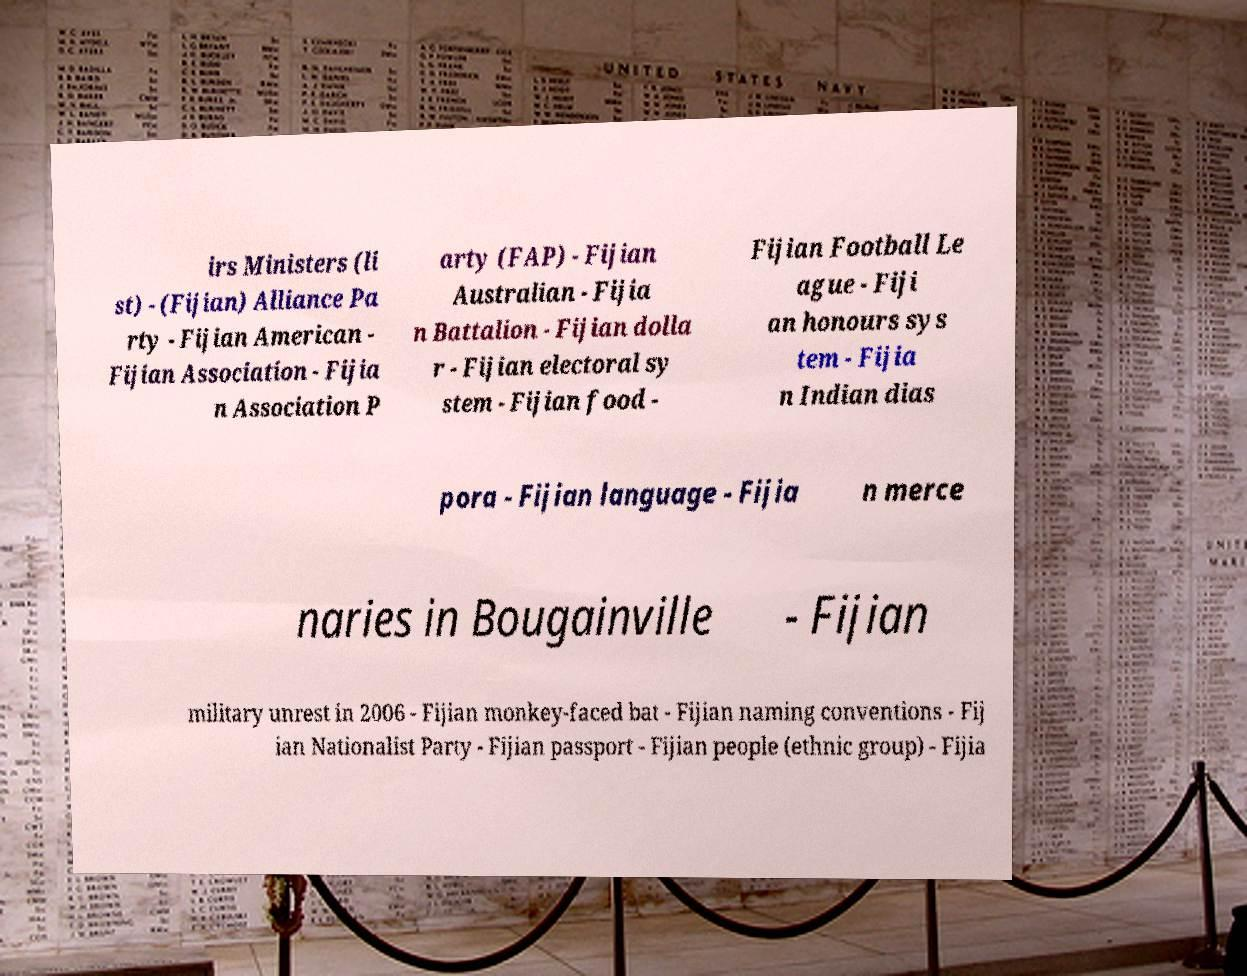For documentation purposes, I need the text within this image transcribed. Could you provide that? irs Ministers (li st) - (Fijian) Alliance Pa rty - Fijian American - Fijian Association - Fijia n Association P arty (FAP) - Fijian Australian - Fijia n Battalion - Fijian dolla r - Fijian electoral sy stem - Fijian food - Fijian Football Le ague - Fiji an honours sys tem - Fijia n Indian dias pora - Fijian language - Fijia n merce naries in Bougainville - Fijian military unrest in 2006 - Fijian monkey-faced bat - Fijian naming conventions - Fij ian Nationalist Party - Fijian passport - Fijian people (ethnic group) - Fijia 